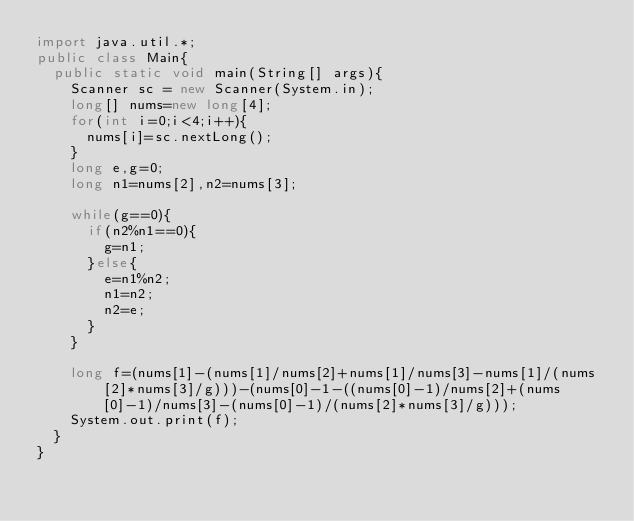<code> <loc_0><loc_0><loc_500><loc_500><_Java_>import java.util.*;
public class Main{
  public static void main(String[] args){
    Scanner sc = new Scanner(System.in);
  	long[] nums=new long[4];
  	for(int i=0;i<4;i++){
  		nums[i]=sc.nextLong();
  	}
  	long e,g=0;
  	long n1=nums[2],n2=nums[3];
  	
  	while(g==0){
  		if(n2%n1==0){
  			g=n1;
  		}else{
  			e=n1%n2;
  			n1=n2;
  			n2=e;
  		}
  	}
  			
  	long f=(nums[1]-(nums[1]/nums[2]+nums[1]/nums[3]-nums[1]/(nums[2]*nums[3]/g)))-(nums[0]-1-((nums[0]-1)/nums[2]+(nums[0]-1)/nums[3]-(nums[0]-1)/(nums[2]*nums[3]/g)));
  	System.out.print(f);
  }
}</code> 